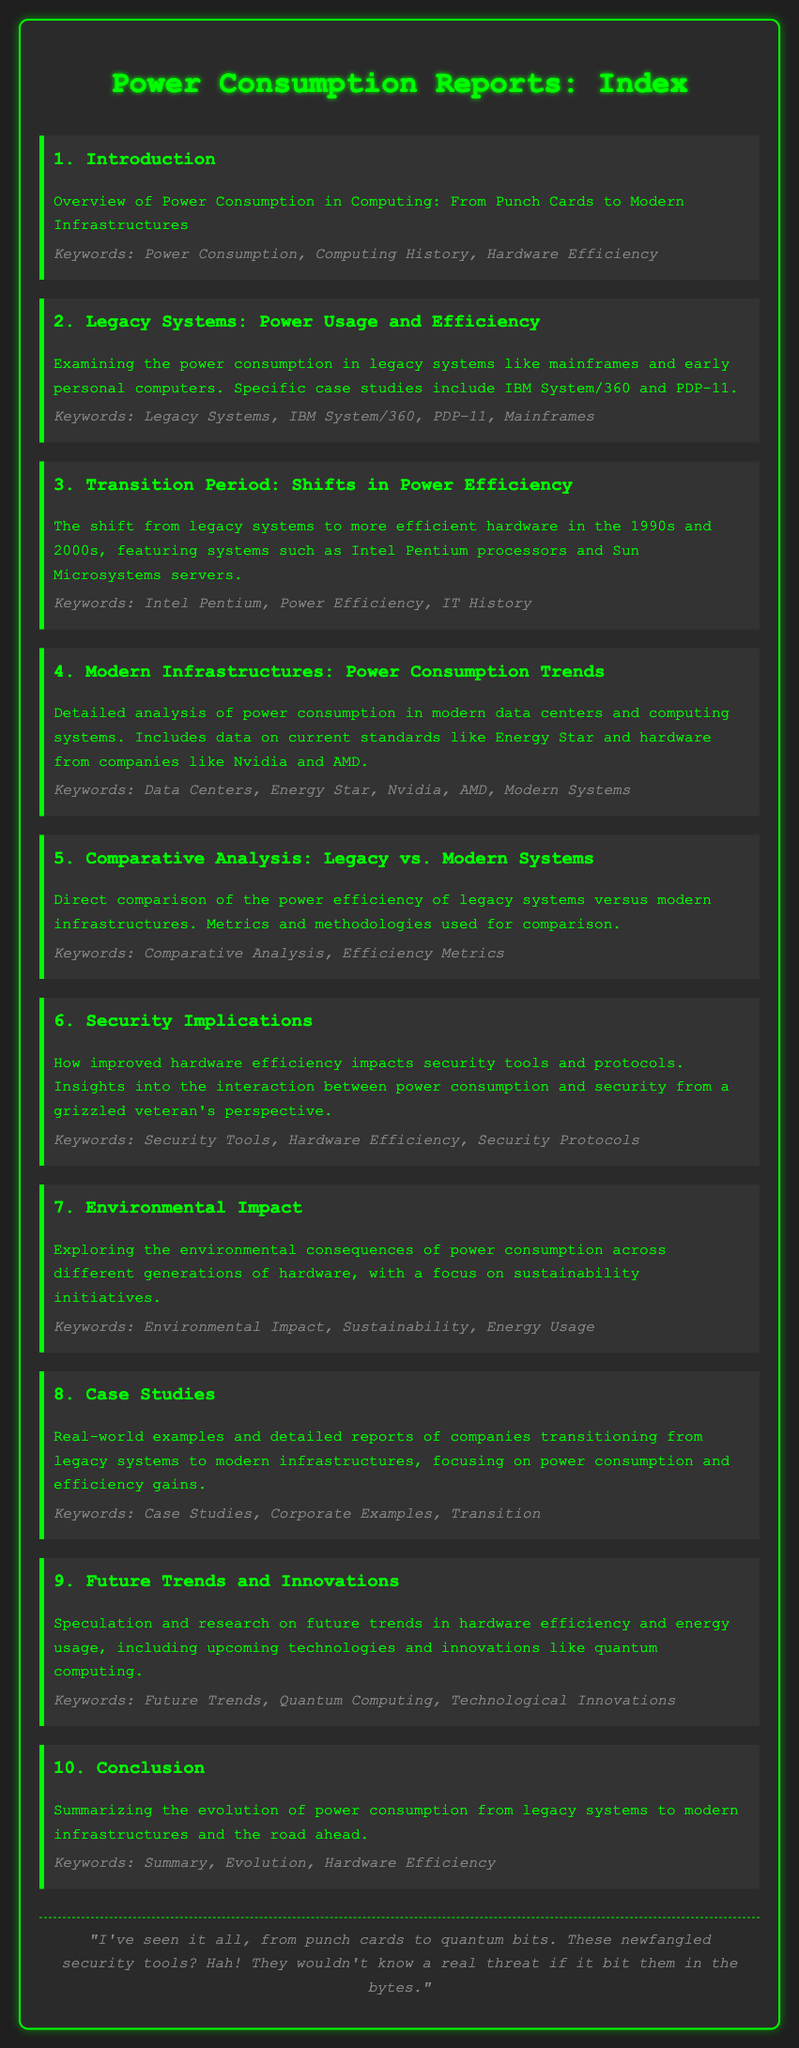what is the title of the document? The title is clearly stated in the header of the document and provides an overview of its content.
Answer: Power Consumption Reports: Index what is the focus of section 2? Section 2 provides an examination of legacy systems in power consumption and specific case studies.
Answer: Power Usage and Efficiency which hardware is specifically mentioned in section 4? Section 4 details current hardware involved in power consumption analysis, naming specific companies and technologies.
Answer: Nvidia and AMD how many sections are in the document? The number of sections is directly stated in the index as individual items listed.
Answer: 10 what keywords are associated with modern infrastructures? Each section includes keywords that summarize the content; Section 4 specifically lists relevant terms.
Answer: Data Centers, Energy Star, Nvidia, AMD, Modern Systems what type of examples does section 8 discuss? Section 8 notes the type of content it covers, referring to specific instances of transition from older systems.
Answer: Case Studies what is the final section's main purpose? The last section summarizes findings throughout the document and discusses the evolution of power consumption.
Answer: Conclusion what technological innovation is mentioned in the future trends? Section 9 discusses emerging technologies and future possibilities in computing efficiency.
Answer: Quantum Computing 